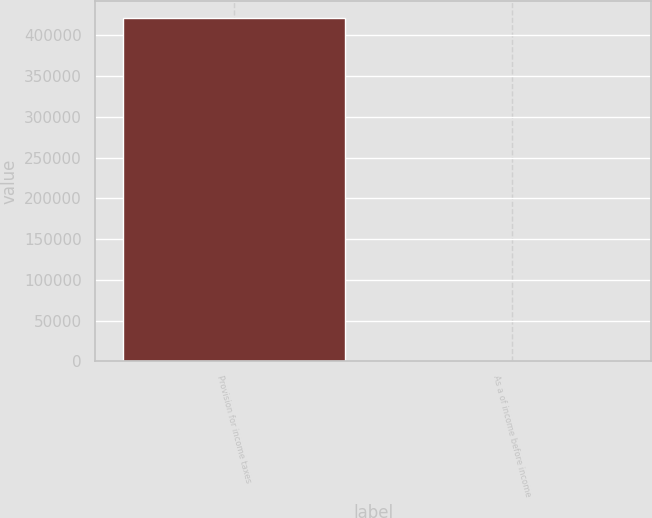Convert chart. <chart><loc_0><loc_0><loc_500><loc_500><bar_chart><fcel>Provision for income taxes<fcel>As a of income before income<nl><fcel>421418<fcel>27<nl></chart> 